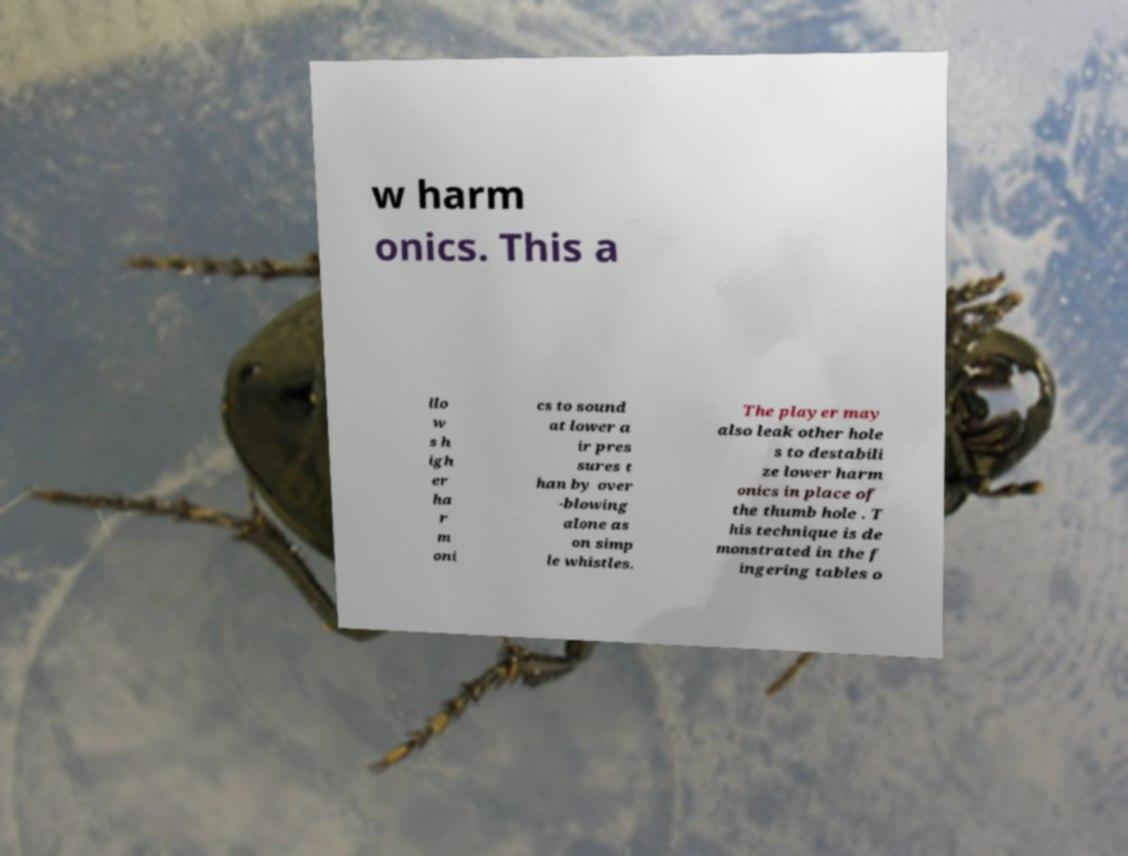Could you assist in decoding the text presented in this image and type it out clearly? w harm onics. This a llo w s h igh er ha r m oni cs to sound at lower a ir pres sures t han by over -blowing alone as on simp le whistles. The player may also leak other hole s to destabili ze lower harm onics in place of the thumb hole . T his technique is de monstrated in the f ingering tables o 